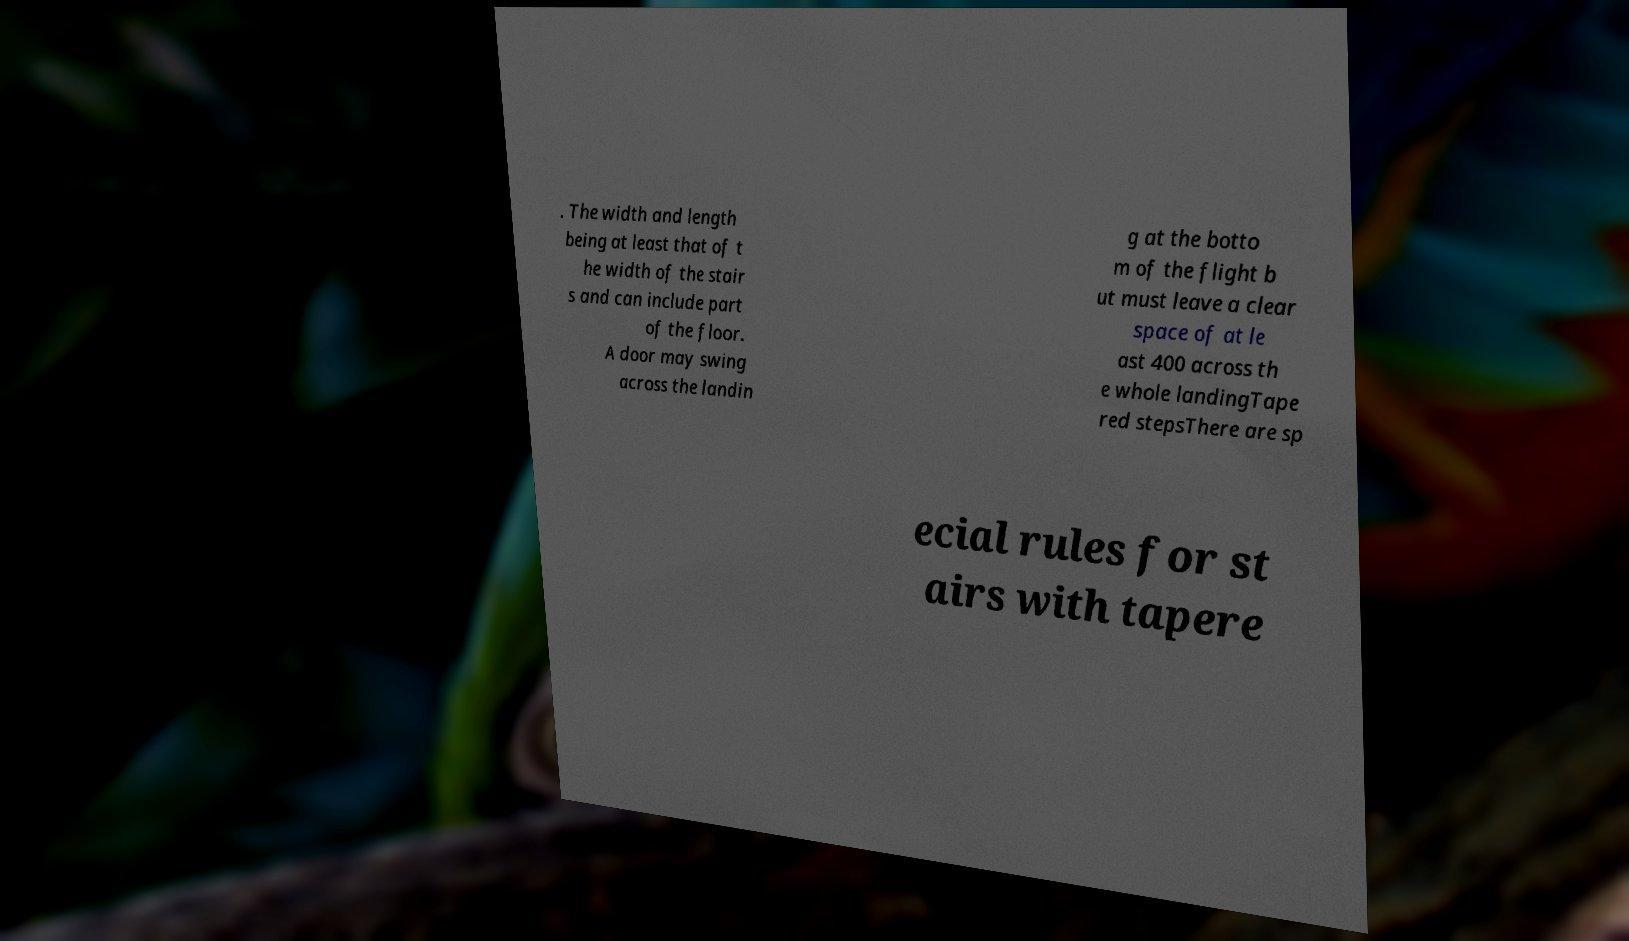Please identify and transcribe the text found in this image. . The width and length being at least that of t he width of the stair s and can include part of the floor. A door may swing across the landin g at the botto m of the flight b ut must leave a clear space of at le ast 400 across th e whole landingTape red stepsThere are sp ecial rules for st airs with tapere 